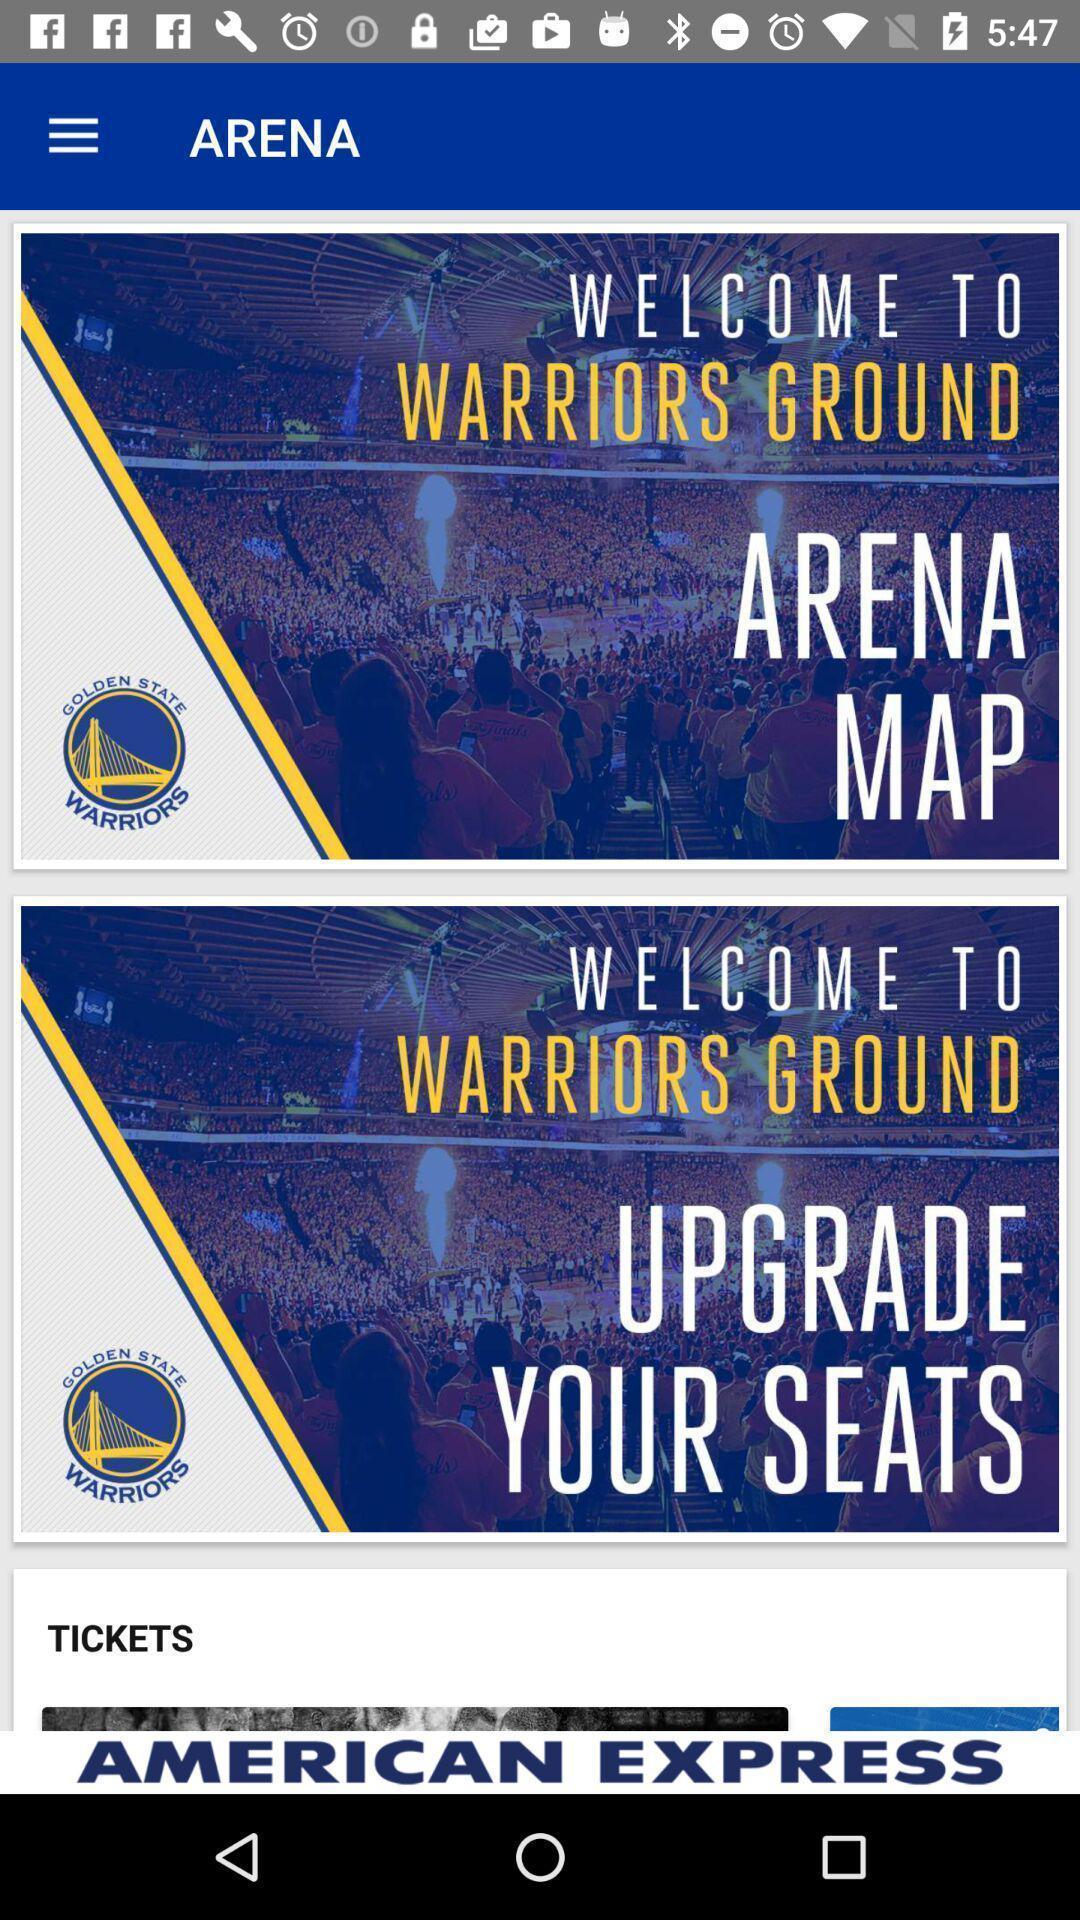Tell me what you see in this picture. Welcome page. 